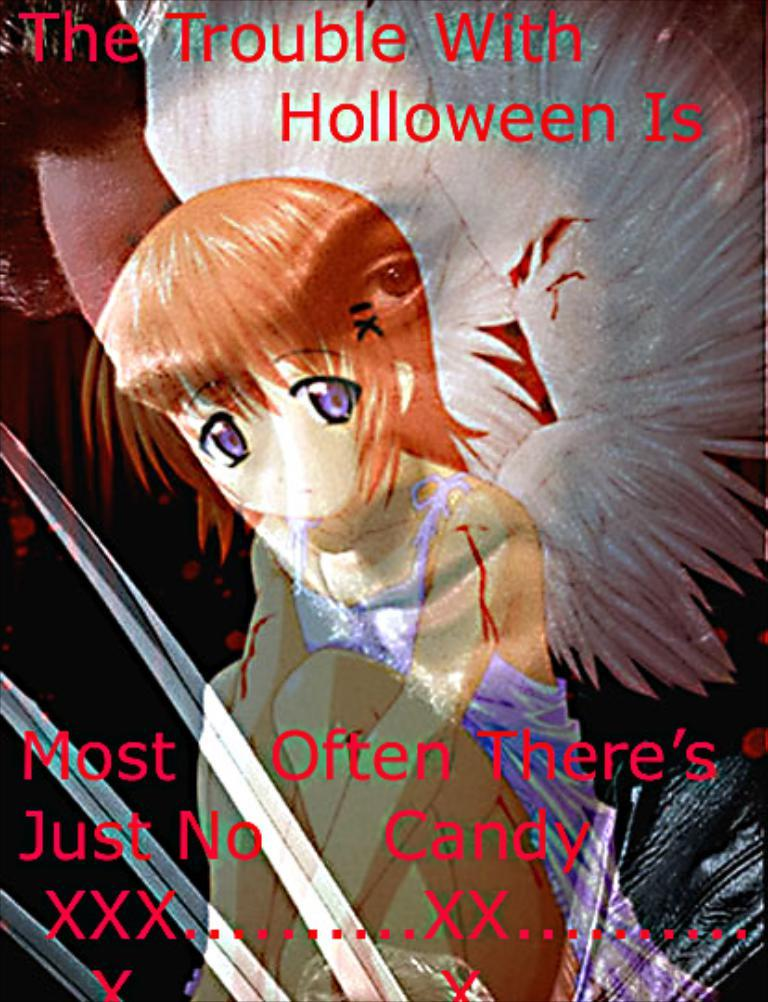What type of image is being described? The image is animated. What additional information can be found on the image? There is a quotation mentioned on the image. What type of dinner is being served in the image? There is no dinner present in the image; it is an animated image with a quotation. What is the weight of the boundary mentioned in the image? There is no boundary mentioned in the image, only a quotation. 